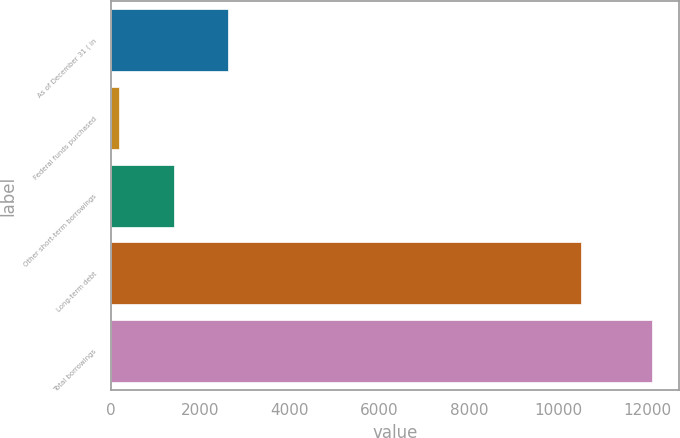Convert chart to OTSL. <chart><loc_0><loc_0><loc_500><loc_500><bar_chart><fcel>As of December 31 ( in<fcel>Federal funds purchased<fcel>Other short-term borrowings<fcel>Long-term debt<fcel>Total borrowings<nl><fcel>2607.2<fcel>182<fcel>1415<fcel>10507<fcel>12104<nl></chart> 